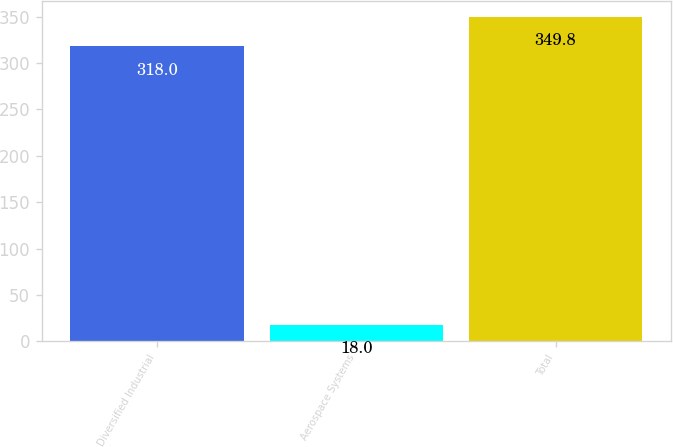Convert chart to OTSL. <chart><loc_0><loc_0><loc_500><loc_500><bar_chart><fcel>Diversified Industrial<fcel>Aerospace Systems<fcel>Total<nl><fcel>318<fcel>18<fcel>349.8<nl></chart> 